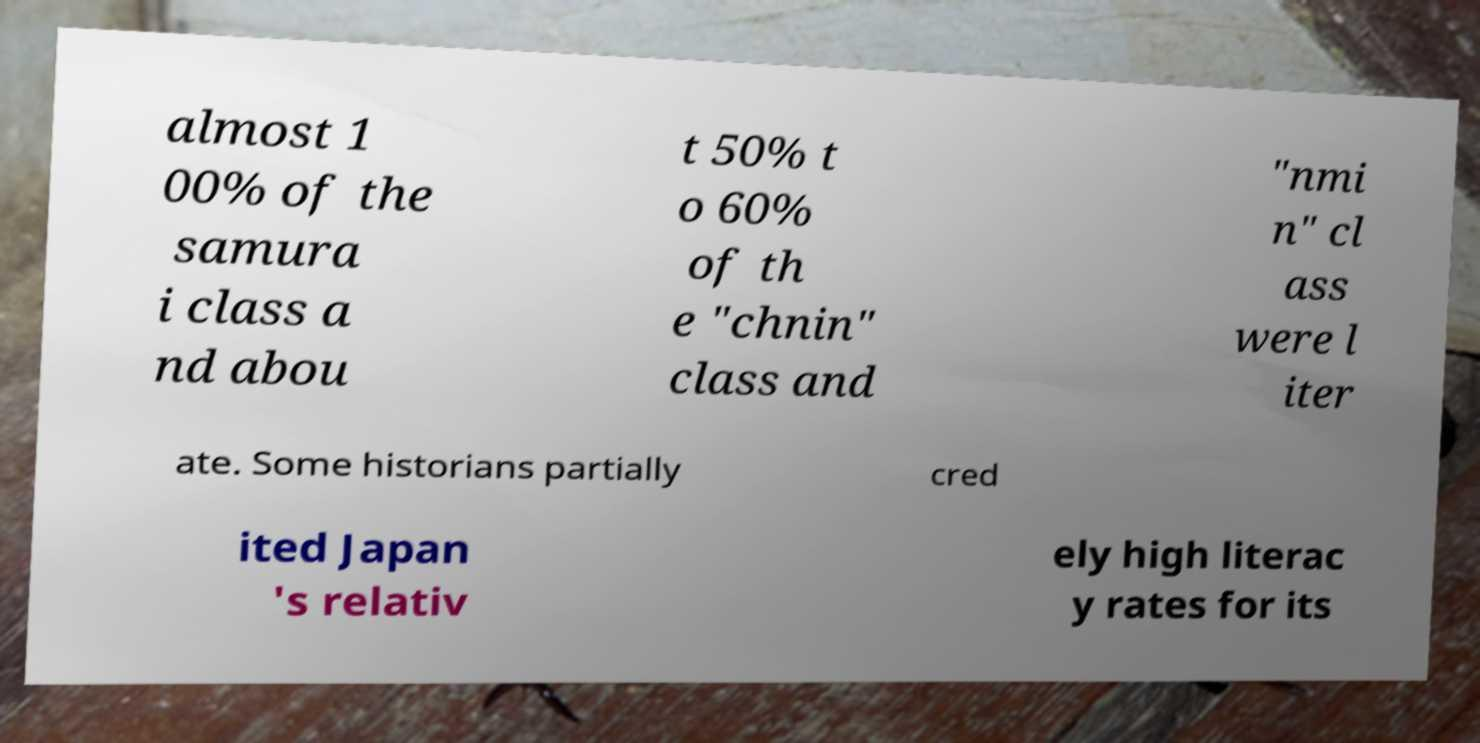Please read and relay the text visible in this image. What does it say? almost 1 00% of the samura i class a nd abou t 50% t o 60% of th e "chnin" class and "nmi n" cl ass were l iter ate. Some historians partially cred ited Japan 's relativ ely high literac y rates for its 